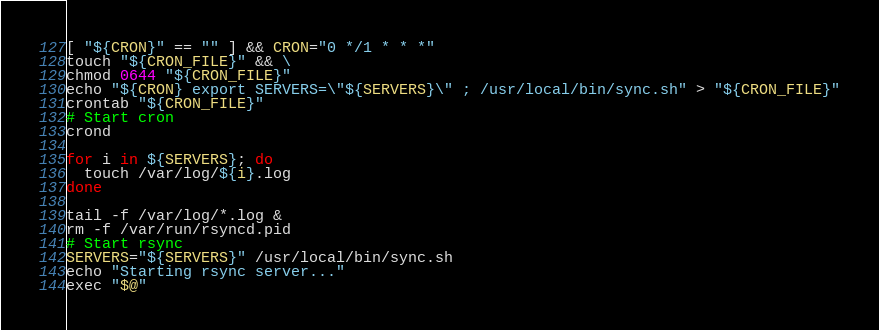Convert code to text. <code><loc_0><loc_0><loc_500><loc_500><_Bash_>[ "${CRON}" == "" ] && CRON="0 */1 * * *"
touch "${CRON_FILE}" && \
chmod 0644 "${CRON_FILE}"
echo "${CRON} export SERVERS=\"${SERVERS}\" ; /usr/local/bin/sync.sh" > "${CRON_FILE}"
crontab "${CRON_FILE}"
# Start cron
crond

for i in ${SERVERS}; do
  touch /var/log/${i}.log
done

tail -f /var/log/*.log &
rm -f /var/run/rsyncd.pid
# Start rsync
SERVERS="${SERVERS}" /usr/local/bin/sync.sh
echo "Starting rsync server..."
exec "$@"
</code> 